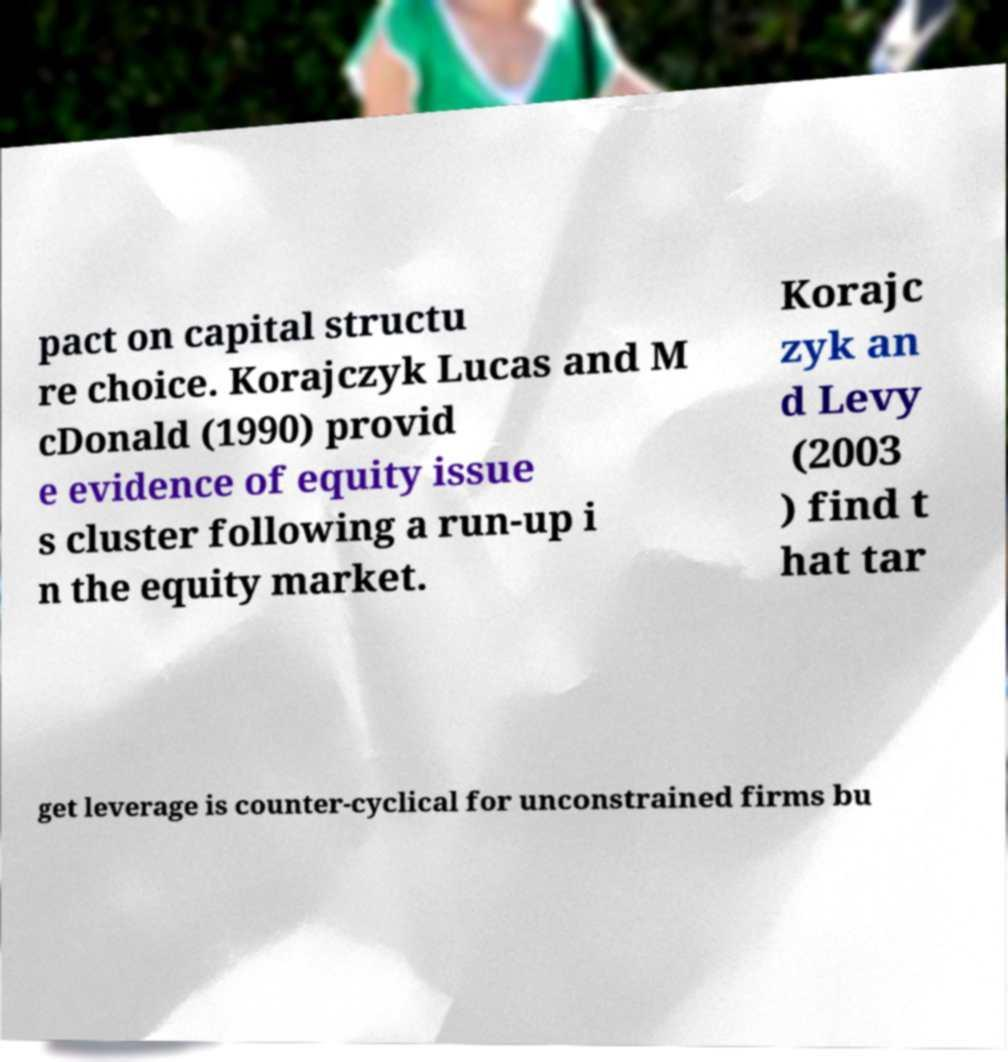For documentation purposes, I need the text within this image transcribed. Could you provide that? pact on capital structu re choice. Korajczyk Lucas and M cDonald (1990) provid e evidence of equity issue s cluster following a run-up i n the equity market. Korajc zyk an d Levy (2003 ) find t hat tar get leverage is counter-cyclical for unconstrained firms bu 